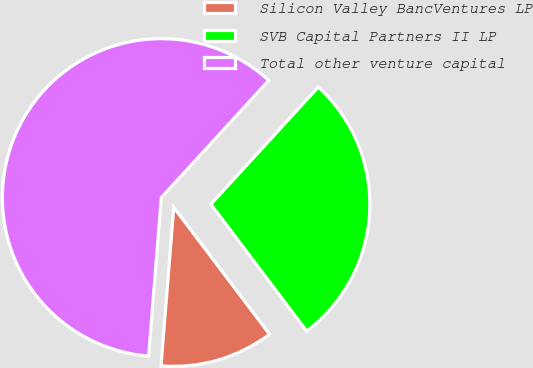Convert chart. <chart><loc_0><loc_0><loc_500><loc_500><pie_chart><fcel>Silicon Valley BancVentures LP<fcel>SVB Capital Partners II LP<fcel>Total other venture capital<nl><fcel>11.57%<fcel>27.9%<fcel>60.53%<nl></chart> 